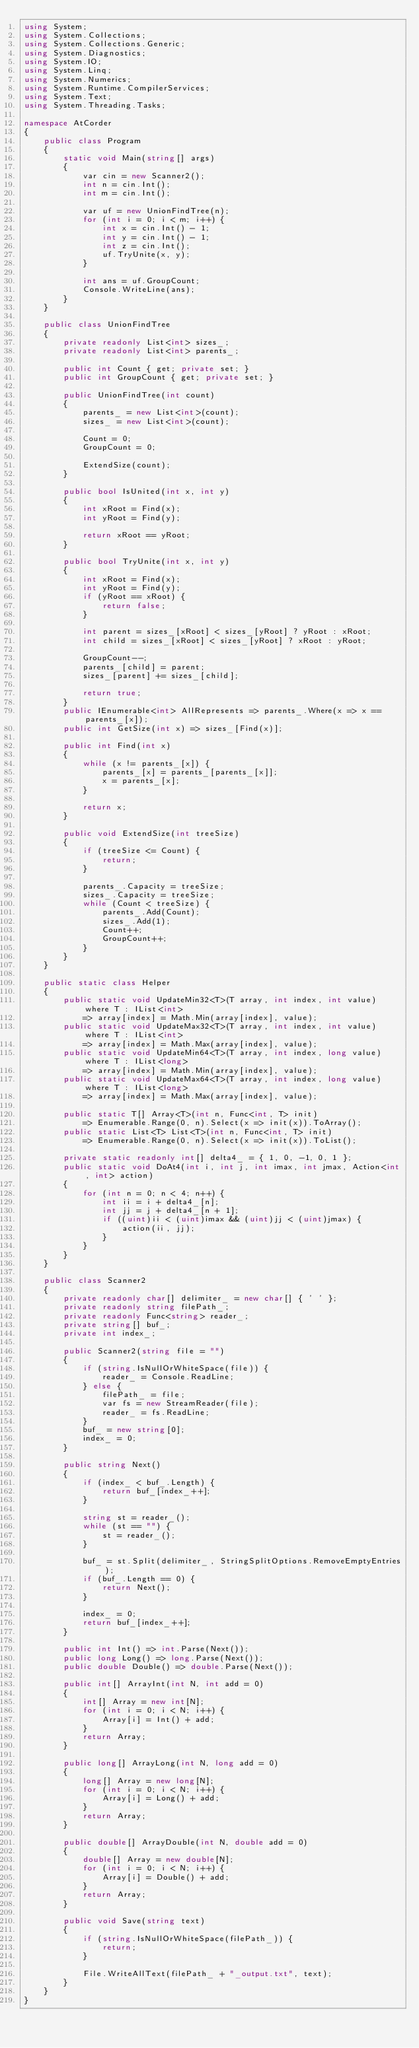Convert code to text. <code><loc_0><loc_0><loc_500><loc_500><_C#_>using System;
using System.Collections;
using System.Collections.Generic;
using System.Diagnostics;
using System.IO;
using System.Linq;
using System.Numerics;
using System.Runtime.CompilerServices;
using System.Text;
using System.Threading.Tasks;

namespace AtCorder
{
	public class Program
	{
		static void Main(string[] args)
		{
			var cin = new Scanner2();
			int n = cin.Int();
			int m = cin.Int();

			var uf = new UnionFindTree(n);
			for (int i = 0; i < m; i++) {
				int x = cin.Int() - 1;
				int y = cin.Int() - 1;
				int z = cin.Int();
				uf.TryUnite(x, y);
			}

			int ans = uf.GroupCount;
			Console.WriteLine(ans);
		}
	}

	public class UnionFindTree
	{
		private readonly List<int> sizes_;
		private readonly List<int> parents_;

		public int Count { get; private set; }
		public int GroupCount { get; private set; }

		public UnionFindTree(int count)
		{
			parents_ = new List<int>(count);
			sizes_ = new List<int>(count);

			Count = 0;
			GroupCount = 0;

			ExtendSize(count);
		}

		public bool IsUnited(int x, int y)
		{
			int xRoot = Find(x);
			int yRoot = Find(y);

			return xRoot == yRoot;
		}

		public bool TryUnite(int x, int y)
		{
			int xRoot = Find(x);
			int yRoot = Find(y);
			if (yRoot == xRoot) {
				return false;
			}

			int parent = sizes_[xRoot] < sizes_[yRoot] ? yRoot : xRoot;
			int child = sizes_[xRoot] < sizes_[yRoot] ? xRoot : yRoot;

			GroupCount--;
			parents_[child] = parent;
			sizes_[parent] += sizes_[child];

			return true;
		}
		public IEnumerable<int> AllRepresents => parents_.Where(x => x == parents_[x]);
		public int GetSize(int x) => sizes_[Find(x)];

		public int Find(int x)
		{
			while (x != parents_[x]) {
				parents_[x] = parents_[parents_[x]];
				x = parents_[x];
			}

			return x;
		}

		public void ExtendSize(int treeSize)
		{
			if (treeSize <= Count) {
				return;
			}

			parents_.Capacity = treeSize;
			sizes_.Capacity = treeSize;
			while (Count < treeSize) {
				parents_.Add(Count);
				sizes_.Add(1);
				Count++;
				GroupCount++;
			}
		}
	}

	public static class Helper
	{
		public static void UpdateMin32<T>(T array, int index, int value) where T : IList<int>
			=> array[index] = Math.Min(array[index], value);
		public static void UpdateMax32<T>(T array, int index, int value) where T : IList<int>
			=> array[index] = Math.Max(array[index], value);
		public static void UpdateMin64<T>(T array, int index, long value) where T : IList<long>
			=> array[index] = Math.Min(array[index], value);
		public static void UpdateMax64<T>(T array, int index, long value) where T : IList<long>
			=> array[index] = Math.Max(array[index], value);

		public static T[] Array<T>(int n, Func<int, T> init)
			=> Enumerable.Range(0, n).Select(x => init(x)).ToArray();
		public static List<T> List<T>(int n, Func<int, T> init)
			=> Enumerable.Range(0, n).Select(x => init(x)).ToList();

		private static readonly int[] delta4_ = { 1, 0, -1, 0, 1 };
		public static void DoAt4(int i, int j, int imax, int jmax, Action<int, int> action)
		{
			for (int n = 0; n < 4; n++) {
				int ii = i + delta4_[n];
				int jj = j + delta4_[n + 1];
				if ((uint)ii < (uint)imax && (uint)jj < (uint)jmax) {
					action(ii, jj);
				}
			}
		}
	}

	public class Scanner2
	{
		private readonly char[] delimiter_ = new char[] { ' ' };
		private readonly string filePath_;
		private readonly Func<string> reader_;
		private string[] buf_;
		private int index_;

		public Scanner2(string file = "")
		{
			if (string.IsNullOrWhiteSpace(file)) {
				reader_ = Console.ReadLine;
			} else {
				filePath_ = file;
				var fs = new StreamReader(file);
				reader_ = fs.ReadLine;
			}
			buf_ = new string[0];
			index_ = 0;
		}

		public string Next()
		{
			if (index_ < buf_.Length) {
				return buf_[index_++];
			}

			string st = reader_();
			while (st == "") {
				st = reader_();
			}

			buf_ = st.Split(delimiter_, StringSplitOptions.RemoveEmptyEntries);
			if (buf_.Length == 0) {
				return Next();
			}

			index_ = 0;
			return buf_[index_++];
		}

		public int Int() => int.Parse(Next());
		public long Long() => long.Parse(Next());
		public double Double() => double.Parse(Next());

		public int[] ArrayInt(int N, int add = 0)
		{
			int[] Array = new int[N];
			for (int i = 0; i < N; i++) {
				Array[i] = Int() + add;
			}
			return Array;
		}

		public long[] ArrayLong(int N, long add = 0)
		{
			long[] Array = new long[N];
			for (int i = 0; i < N; i++) {
				Array[i] = Long() + add;
			}
			return Array;
		}

		public double[] ArrayDouble(int N, double add = 0)
		{
			double[] Array = new double[N];
			for (int i = 0; i < N; i++) {
				Array[i] = Double() + add;
			}
			return Array;
		}

		public void Save(string text)
		{
			if (string.IsNullOrWhiteSpace(filePath_)) {
				return;
			}

			File.WriteAllText(filePath_ + "_output.txt", text);
		}
	}
}</code> 